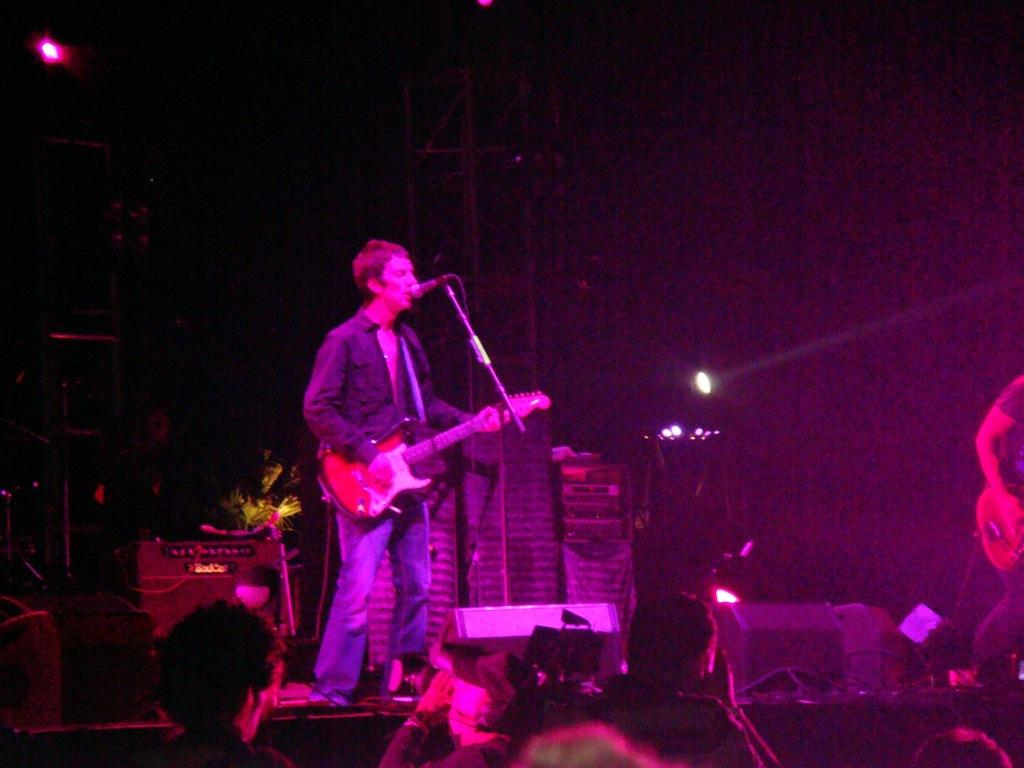What is the man in the image doing? The man is singing on a microphone and playing a guitar. What is the man's posture in the image? The man is standing in the image. What can be seen in the background of the image? There is a light in the background of the image. Are there any other people present in the image? Yes, there are people present in the image. What type of star can be seen in the image? There is no star visible in the image. What is the man using to play the guitar in the image? The man is playing the guitar with his hands, not a pipe. 